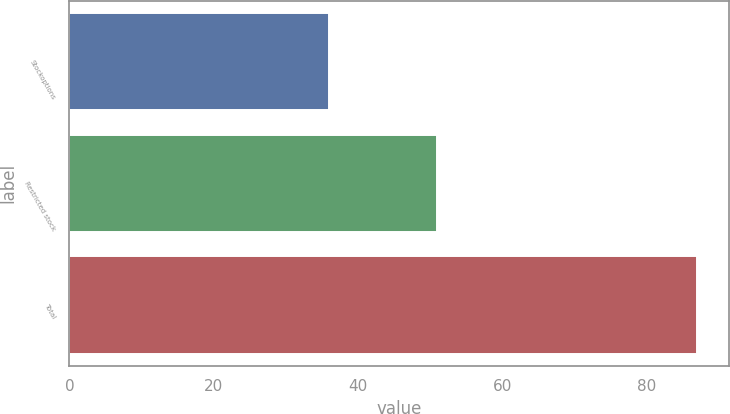Convert chart to OTSL. <chart><loc_0><loc_0><loc_500><loc_500><bar_chart><fcel>Stockoptions<fcel>Restricted stock<fcel>Total<nl><fcel>36<fcel>51<fcel>87<nl></chart> 